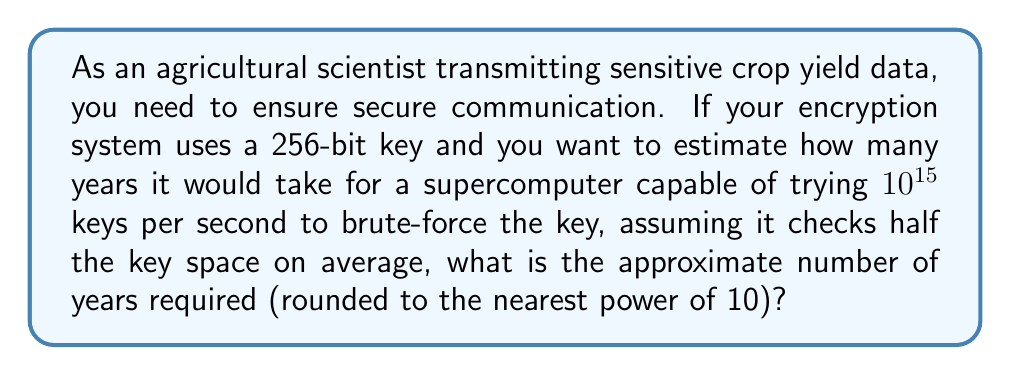Show me your answer to this math problem. To solve this problem, we'll follow these steps:

1) First, calculate the total number of possible keys:
   $$\text{Total keys} = 2^{256}$$

2) The average number of keys that need to be tried is half of this:
   $$\text{Average keys to try} = \frac{2^{256}}{2} = 2^{255}$$

3) Convert the supercomputer's speed to keys per year:
   $$\text{Keys per year} = 10^{15} \times 60 \times 60 \times 24 \times 365.25 \approx 3.16 \times 10^{22}$$

4) Calculate the time required in years:
   $$\text{Years} = \frac{2^{255}}{3.16 \times 10^{22}}$$

5) Simplify:
   $$\begin{align}
   \text{Years} &= \frac{2^{255}}{3.16 \times 10^{22}} \\
   &\approx \frac{5.79 \times 10^{76}}{3.16 \times 10^{22}} \\
   &\approx 1.83 \times 10^{54}
   \end{align}$$

6) Round to the nearest power of 10:
   $$\text{Years} \approx 10^{54}$$

This immense number demonstrates the strength of a 256-bit key for securing agricultural data transmission.
Answer: $10^{54}$ years 